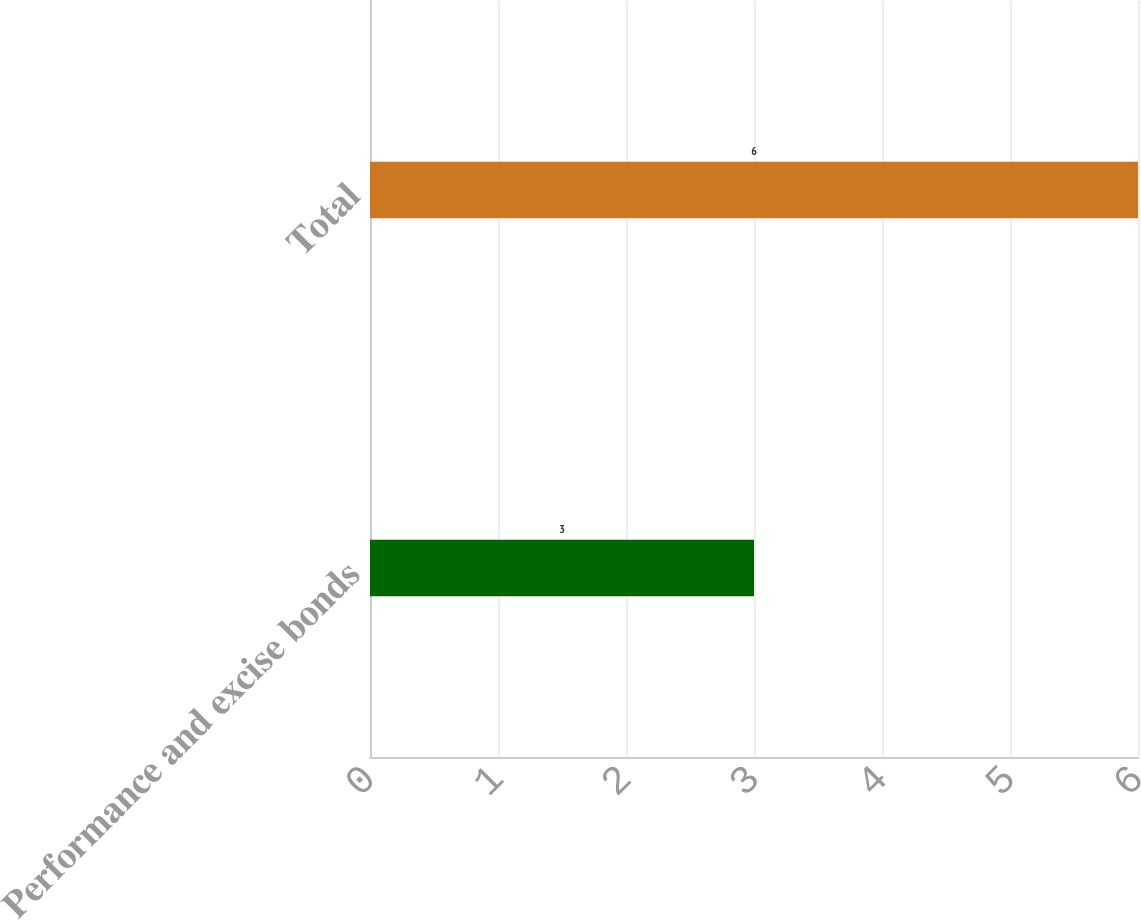Convert chart to OTSL. <chart><loc_0><loc_0><loc_500><loc_500><bar_chart><fcel>Performance and excise bonds<fcel>Total<nl><fcel>3<fcel>6<nl></chart> 